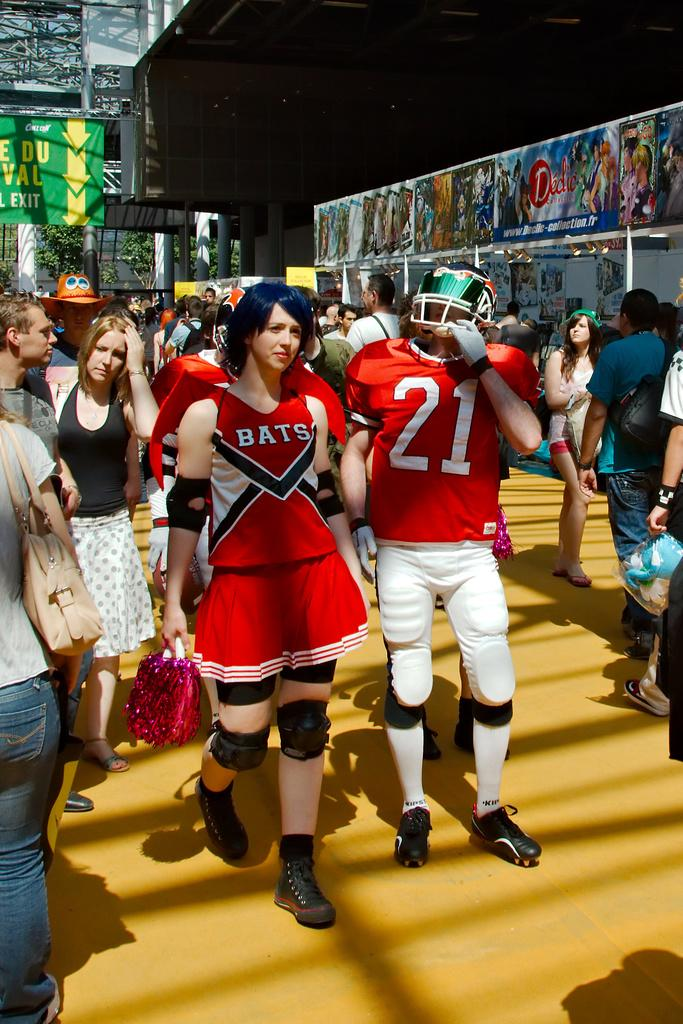What can be seen on the right side of the image? There are people and posters on the right side of the image. What can be seen on the left side of the image? There are people and posters on the left side of the image. Can you describe the posters in the image? The posters are located on both the right and left sides of the image. Is there a bridge visible in the image? There is no bridge present in the image. Can you describe the sidewalk in the image? There is no sidewalk mentioned in the provided facts, so it cannot be described. 